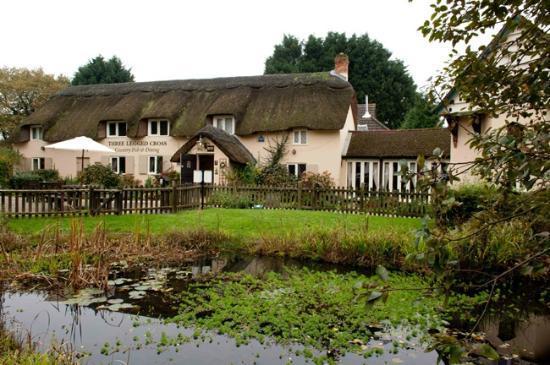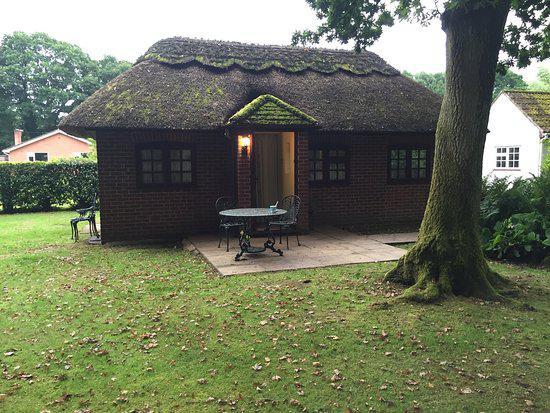The first image is the image on the left, the second image is the image on the right. Examine the images to the left and right. Is the description "Patio furniture is in front of a house." accurate? Answer yes or no. Yes. The first image is the image on the left, the second image is the image on the right. For the images displayed, is the sentence "One of the houses has a swimming pool." factually correct? Answer yes or no. No. 